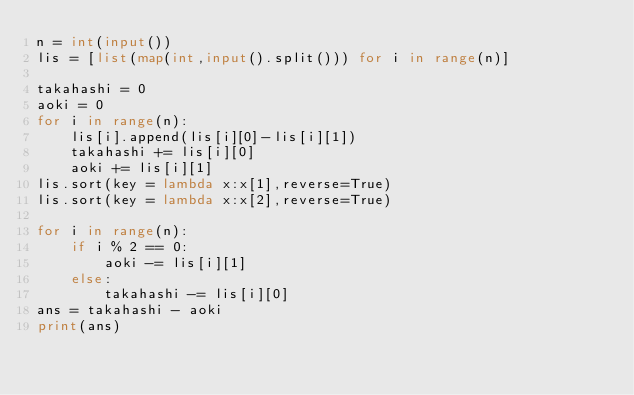<code> <loc_0><loc_0><loc_500><loc_500><_Python_>n = int(input())
lis = [list(map(int,input().split())) for i in range(n)]

takahashi = 0
aoki = 0
for i in range(n):
    lis[i].append(lis[i][0]-lis[i][1])
    takahashi += lis[i][0]
    aoki += lis[i][1]
lis.sort(key = lambda x:x[1],reverse=True)
lis.sort(key = lambda x:x[2],reverse=True)

for i in range(n):
    if i % 2 == 0:
        aoki -= lis[i][1]
    else:
        takahashi -= lis[i][0]
ans = takahashi - aoki
print(ans)</code> 